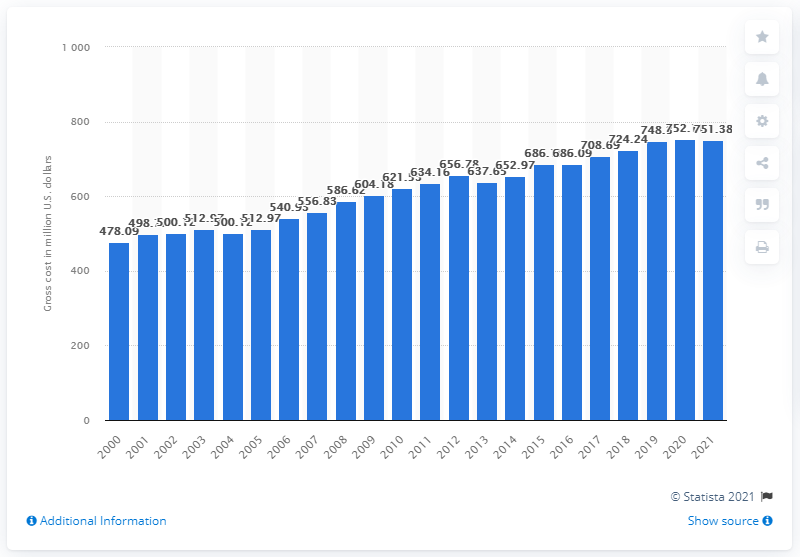Indicate a few pertinent items in this graphic. The gross cost of fishing licenses in the United States in 2021 was approximately $751.38. 